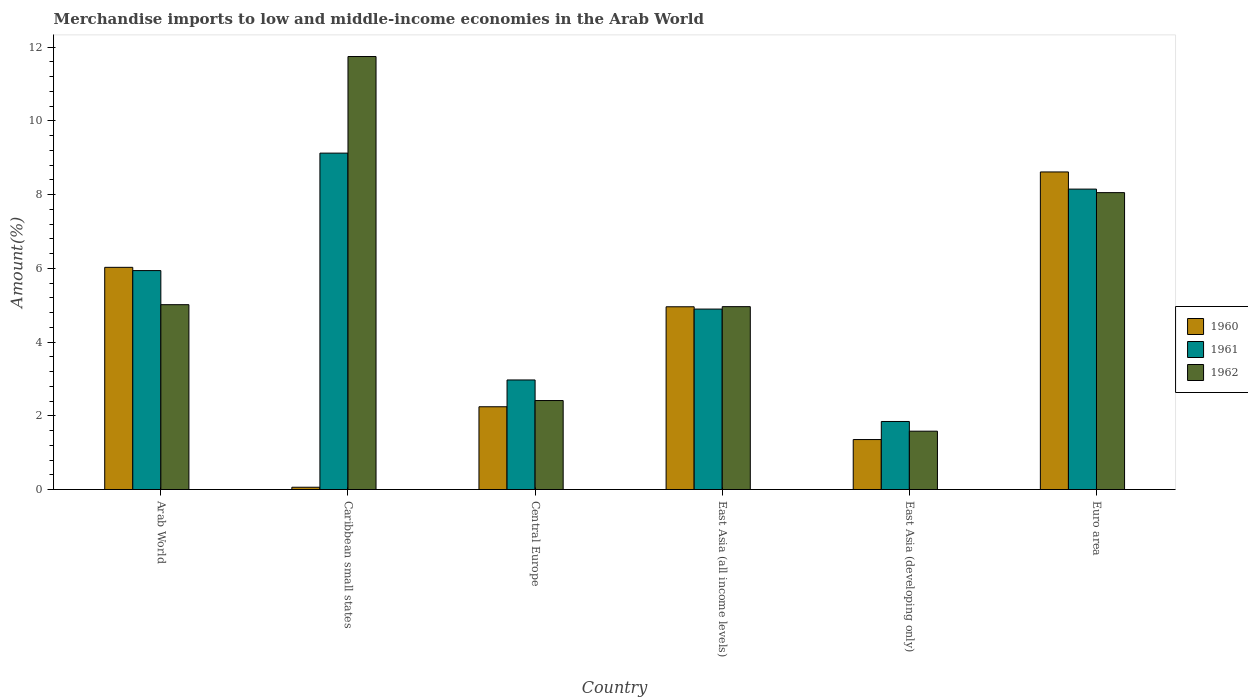How many different coloured bars are there?
Make the answer very short. 3. How many groups of bars are there?
Your answer should be compact. 6. Are the number of bars per tick equal to the number of legend labels?
Ensure brevity in your answer.  Yes. Are the number of bars on each tick of the X-axis equal?
Make the answer very short. Yes. What is the label of the 2nd group of bars from the left?
Give a very brief answer. Caribbean small states. In how many cases, is the number of bars for a given country not equal to the number of legend labels?
Your answer should be very brief. 0. What is the percentage of amount earned from merchandise imports in 1960 in Caribbean small states?
Offer a very short reply. 0.06. Across all countries, what is the maximum percentage of amount earned from merchandise imports in 1961?
Give a very brief answer. 9.13. Across all countries, what is the minimum percentage of amount earned from merchandise imports in 1962?
Your response must be concise. 1.58. In which country was the percentage of amount earned from merchandise imports in 1961 maximum?
Your response must be concise. Caribbean small states. In which country was the percentage of amount earned from merchandise imports in 1962 minimum?
Make the answer very short. East Asia (developing only). What is the total percentage of amount earned from merchandise imports in 1960 in the graph?
Make the answer very short. 23.27. What is the difference between the percentage of amount earned from merchandise imports in 1960 in Caribbean small states and that in Central Europe?
Offer a very short reply. -2.18. What is the difference between the percentage of amount earned from merchandise imports in 1962 in East Asia (all income levels) and the percentage of amount earned from merchandise imports in 1960 in Caribbean small states?
Provide a succinct answer. 4.9. What is the average percentage of amount earned from merchandise imports in 1962 per country?
Provide a succinct answer. 5.63. What is the difference between the percentage of amount earned from merchandise imports of/in 1962 and percentage of amount earned from merchandise imports of/in 1960 in Caribbean small states?
Provide a short and direct response. 11.69. What is the ratio of the percentage of amount earned from merchandise imports in 1961 in Arab World to that in East Asia (developing only)?
Your answer should be compact. 3.22. Is the difference between the percentage of amount earned from merchandise imports in 1962 in Caribbean small states and East Asia (developing only) greater than the difference between the percentage of amount earned from merchandise imports in 1960 in Caribbean small states and East Asia (developing only)?
Your answer should be compact. Yes. What is the difference between the highest and the second highest percentage of amount earned from merchandise imports in 1960?
Your response must be concise. 3.66. What is the difference between the highest and the lowest percentage of amount earned from merchandise imports in 1961?
Your answer should be very brief. 7.28. In how many countries, is the percentage of amount earned from merchandise imports in 1961 greater than the average percentage of amount earned from merchandise imports in 1961 taken over all countries?
Ensure brevity in your answer.  3. What does the 2nd bar from the left in Euro area represents?
Give a very brief answer. 1961. How many bars are there?
Provide a succinct answer. 18. How many countries are there in the graph?
Offer a very short reply. 6. What is the difference between two consecutive major ticks on the Y-axis?
Offer a very short reply. 2. Does the graph contain grids?
Give a very brief answer. No. How many legend labels are there?
Your answer should be compact. 3. What is the title of the graph?
Ensure brevity in your answer.  Merchandise imports to low and middle-income economies in the Arab World. Does "1962" appear as one of the legend labels in the graph?
Your answer should be compact. Yes. What is the label or title of the X-axis?
Your response must be concise. Country. What is the label or title of the Y-axis?
Give a very brief answer. Amount(%). What is the Amount(%) of 1960 in Arab World?
Make the answer very short. 6.03. What is the Amount(%) of 1961 in Arab World?
Ensure brevity in your answer.  5.94. What is the Amount(%) of 1962 in Arab World?
Offer a very short reply. 5.01. What is the Amount(%) in 1960 in Caribbean small states?
Offer a very short reply. 0.06. What is the Amount(%) of 1961 in Caribbean small states?
Ensure brevity in your answer.  9.13. What is the Amount(%) of 1962 in Caribbean small states?
Your answer should be compact. 11.75. What is the Amount(%) in 1960 in Central Europe?
Make the answer very short. 2.25. What is the Amount(%) of 1961 in Central Europe?
Your answer should be compact. 2.97. What is the Amount(%) in 1962 in Central Europe?
Your response must be concise. 2.41. What is the Amount(%) of 1960 in East Asia (all income levels)?
Your answer should be very brief. 4.96. What is the Amount(%) in 1961 in East Asia (all income levels)?
Your answer should be compact. 4.9. What is the Amount(%) in 1962 in East Asia (all income levels)?
Keep it short and to the point. 4.96. What is the Amount(%) in 1960 in East Asia (developing only)?
Give a very brief answer. 1.36. What is the Amount(%) of 1961 in East Asia (developing only)?
Make the answer very short. 1.85. What is the Amount(%) in 1962 in East Asia (developing only)?
Provide a succinct answer. 1.58. What is the Amount(%) of 1960 in Euro area?
Your response must be concise. 8.62. What is the Amount(%) in 1961 in Euro area?
Keep it short and to the point. 8.15. What is the Amount(%) of 1962 in Euro area?
Make the answer very short. 8.05. Across all countries, what is the maximum Amount(%) in 1960?
Keep it short and to the point. 8.62. Across all countries, what is the maximum Amount(%) in 1961?
Your answer should be compact. 9.13. Across all countries, what is the maximum Amount(%) in 1962?
Your answer should be compact. 11.75. Across all countries, what is the minimum Amount(%) of 1960?
Provide a short and direct response. 0.06. Across all countries, what is the minimum Amount(%) in 1961?
Your answer should be very brief. 1.85. Across all countries, what is the minimum Amount(%) in 1962?
Ensure brevity in your answer.  1.58. What is the total Amount(%) in 1960 in the graph?
Make the answer very short. 23.27. What is the total Amount(%) of 1961 in the graph?
Offer a terse response. 32.93. What is the total Amount(%) in 1962 in the graph?
Your answer should be compact. 33.78. What is the difference between the Amount(%) in 1960 in Arab World and that in Caribbean small states?
Offer a very short reply. 5.97. What is the difference between the Amount(%) in 1961 in Arab World and that in Caribbean small states?
Offer a terse response. -3.19. What is the difference between the Amount(%) of 1962 in Arab World and that in Caribbean small states?
Provide a succinct answer. -6.73. What is the difference between the Amount(%) of 1960 in Arab World and that in Central Europe?
Make the answer very short. 3.78. What is the difference between the Amount(%) in 1961 in Arab World and that in Central Europe?
Offer a very short reply. 2.97. What is the difference between the Amount(%) in 1962 in Arab World and that in Central Europe?
Provide a succinct answer. 2.6. What is the difference between the Amount(%) in 1960 in Arab World and that in East Asia (all income levels)?
Keep it short and to the point. 1.07. What is the difference between the Amount(%) of 1961 in Arab World and that in East Asia (all income levels)?
Your answer should be compact. 1.04. What is the difference between the Amount(%) of 1962 in Arab World and that in East Asia (all income levels)?
Give a very brief answer. 0.05. What is the difference between the Amount(%) in 1960 in Arab World and that in East Asia (developing only)?
Provide a succinct answer. 4.67. What is the difference between the Amount(%) of 1961 in Arab World and that in East Asia (developing only)?
Offer a very short reply. 4.09. What is the difference between the Amount(%) in 1962 in Arab World and that in East Asia (developing only)?
Keep it short and to the point. 3.43. What is the difference between the Amount(%) in 1960 in Arab World and that in Euro area?
Your answer should be compact. -2.59. What is the difference between the Amount(%) in 1961 in Arab World and that in Euro area?
Your answer should be very brief. -2.21. What is the difference between the Amount(%) in 1962 in Arab World and that in Euro area?
Offer a very short reply. -3.04. What is the difference between the Amount(%) of 1960 in Caribbean small states and that in Central Europe?
Your answer should be very brief. -2.18. What is the difference between the Amount(%) of 1961 in Caribbean small states and that in Central Europe?
Provide a short and direct response. 6.15. What is the difference between the Amount(%) in 1962 in Caribbean small states and that in Central Europe?
Keep it short and to the point. 9.33. What is the difference between the Amount(%) in 1960 in Caribbean small states and that in East Asia (all income levels)?
Provide a succinct answer. -4.9. What is the difference between the Amount(%) of 1961 in Caribbean small states and that in East Asia (all income levels)?
Your response must be concise. 4.23. What is the difference between the Amount(%) in 1962 in Caribbean small states and that in East Asia (all income levels)?
Your response must be concise. 6.79. What is the difference between the Amount(%) in 1960 in Caribbean small states and that in East Asia (developing only)?
Your answer should be very brief. -1.29. What is the difference between the Amount(%) of 1961 in Caribbean small states and that in East Asia (developing only)?
Offer a terse response. 7.28. What is the difference between the Amount(%) of 1962 in Caribbean small states and that in East Asia (developing only)?
Provide a succinct answer. 10.16. What is the difference between the Amount(%) of 1960 in Caribbean small states and that in Euro area?
Provide a short and direct response. -8.55. What is the difference between the Amount(%) in 1961 in Caribbean small states and that in Euro area?
Make the answer very short. 0.98. What is the difference between the Amount(%) of 1962 in Caribbean small states and that in Euro area?
Ensure brevity in your answer.  3.69. What is the difference between the Amount(%) of 1960 in Central Europe and that in East Asia (all income levels)?
Give a very brief answer. -2.71. What is the difference between the Amount(%) in 1961 in Central Europe and that in East Asia (all income levels)?
Provide a succinct answer. -1.92. What is the difference between the Amount(%) in 1962 in Central Europe and that in East Asia (all income levels)?
Your answer should be compact. -2.55. What is the difference between the Amount(%) in 1960 in Central Europe and that in East Asia (developing only)?
Provide a short and direct response. 0.89. What is the difference between the Amount(%) in 1961 in Central Europe and that in East Asia (developing only)?
Ensure brevity in your answer.  1.13. What is the difference between the Amount(%) in 1962 in Central Europe and that in East Asia (developing only)?
Offer a very short reply. 0.83. What is the difference between the Amount(%) of 1960 in Central Europe and that in Euro area?
Ensure brevity in your answer.  -6.37. What is the difference between the Amount(%) of 1961 in Central Europe and that in Euro area?
Your answer should be compact. -5.18. What is the difference between the Amount(%) in 1962 in Central Europe and that in Euro area?
Provide a succinct answer. -5.64. What is the difference between the Amount(%) in 1960 in East Asia (all income levels) and that in East Asia (developing only)?
Make the answer very short. 3.6. What is the difference between the Amount(%) in 1961 in East Asia (all income levels) and that in East Asia (developing only)?
Provide a succinct answer. 3.05. What is the difference between the Amount(%) of 1962 in East Asia (all income levels) and that in East Asia (developing only)?
Make the answer very short. 3.38. What is the difference between the Amount(%) of 1960 in East Asia (all income levels) and that in Euro area?
Make the answer very short. -3.66. What is the difference between the Amount(%) in 1961 in East Asia (all income levels) and that in Euro area?
Offer a very short reply. -3.26. What is the difference between the Amount(%) of 1962 in East Asia (all income levels) and that in Euro area?
Your answer should be very brief. -3.09. What is the difference between the Amount(%) of 1960 in East Asia (developing only) and that in Euro area?
Ensure brevity in your answer.  -7.26. What is the difference between the Amount(%) in 1961 in East Asia (developing only) and that in Euro area?
Keep it short and to the point. -6.3. What is the difference between the Amount(%) of 1962 in East Asia (developing only) and that in Euro area?
Give a very brief answer. -6.47. What is the difference between the Amount(%) in 1960 in Arab World and the Amount(%) in 1961 in Caribbean small states?
Give a very brief answer. -3.1. What is the difference between the Amount(%) of 1960 in Arab World and the Amount(%) of 1962 in Caribbean small states?
Provide a succinct answer. -5.72. What is the difference between the Amount(%) in 1961 in Arab World and the Amount(%) in 1962 in Caribbean small states?
Provide a succinct answer. -5.81. What is the difference between the Amount(%) of 1960 in Arab World and the Amount(%) of 1961 in Central Europe?
Make the answer very short. 3.06. What is the difference between the Amount(%) in 1960 in Arab World and the Amount(%) in 1962 in Central Europe?
Offer a very short reply. 3.61. What is the difference between the Amount(%) in 1961 in Arab World and the Amount(%) in 1962 in Central Europe?
Give a very brief answer. 3.53. What is the difference between the Amount(%) in 1960 in Arab World and the Amount(%) in 1961 in East Asia (all income levels)?
Make the answer very short. 1.13. What is the difference between the Amount(%) of 1960 in Arab World and the Amount(%) of 1962 in East Asia (all income levels)?
Offer a terse response. 1.07. What is the difference between the Amount(%) in 1961 in Arab World and the Amount(%) in 1962 in East Asia (all income levels)?
Keep it short and to the point. 0.98. What is the difference between the Amount(%) in 1960 in Arab World and the Amount(%) in 1961 in East Asia (developing only)?
Offer a very short reply. 4.18. What is the difference between the Amount(%) in 1960 in Arab World and the Amount(%) in 1962 in East Asia (developing only)?
Your answer should be compact. 4.45. What is the difference between the Amount(%) of 1961 in Arab World and the Amount(%) of 1962 in East Asia (developing only)?
Ensure brevity in your answer.  4.36. What is the difference between the Amount(%) of 1960 in Arab World and the Amount(%) of 1961 in Euro area?
Offer a very short reply. -2.12. What is the difference between the Amount(%) of 1960 in Arab World and the Amount(%) of 1962 in Euro area?
Offer a terse response. -2.03. What is the difference between the Amount(%) in 1961 in Arab World and the Amount(%) in 1962 in Euro area?
Provide a succinct answer. -2.12. What is the difference between the Amount(%) of 1960 in Caribbean small states and the Amount(%) of 1961 in Central Europe?
Give a very brief answer. -2.91. What is the difference between the Amount(%) of 1960 in Caribbean small states and the Amount(%) of 1962 in Central Europe?
Provide a succinct answer. -2.35. What is the difference between the Amount(%) in 1961 in Caribbean small states and the Amount(%) in 1962 in Central Europe?
Ensure brevity in your answer.  6.71. What is the difference between the Amount(%) of 1960 in Caribbean small states and the Amount(%) of 1961 in East Asia (all income levels)?
Your answer should be compact. -4.83. What is the difference between the Amount(%) of 1961 in Caribbean small states and the Amount(%) of 1962 in East Asia (all income levels)?
Ensure brevity in your answer.  4.17. What is the difference between the Amount(%) of 1960 in Caribbean small states and the Amount(%) of 1961 in East Asia (developing only)?
Provide a succinct answer. -1.78. What is the difference between the Amount(%) in 1960 in Caribbean small states and the Amount(%) in 1962 in East Asia (developing only)?
Your answer should be very brief. -1.52. What is the difference between the Amount(%) in 1961 in Caribbean small states and the Amount(%) in 1962 in East Asia (developing only)?
Provide a succinct answer. 7.54. What is the difference between the Amount(%) in 1960 in Caribbean small states and the Amount(%) in 1961 in Euro area?
Keep it short and to the point. -8.09. What is the difference between the Amount(%) of 1960 in Caribbean small states and the Amount(%) of 1962 in Euro area?
Provide a short and direct response. -7.99. What is the difference between the Amount(%) in 1961 in Caribbean small states and the Amount(%) in 1962 in Euro area?
Your response must be concise. 1.07. What is the difference between the Amount(%) in 1960 in Central Europe and the Amount(%) in 1961 in East Asia (all income levels)?
Make the answer very short. -2.65. What is the difference between the Amount(%) of 1960 in Central Europe and the Amount(%) of 1962 in East Asia (all income levels)?
Give a very brief answer. -2.72. What is the difference between the Amount(%) in 1961 in Central Europe and the Amount(%) in 1962 in East Asia (all income levels)?
Offer a terse response. -1.99. What is the difference between the Amount(%) in 1960 in Central Europe and the Amount(%) in 1961 in East Asia (developing only)?
Provide a short and direct response. 0.4. What is the difference between the Amount(%) in 1960 in Central Europe and the Amount(%) in 1962 in East Asia (developing only)?
Make the answer very short. 0.66. What is the difference between the Amount(%) of 1961 in Central Europe and the Amount(%) of 1962 in East Asia (developing only)?
Offer a very short reply. 1.39. What is the difference between the Amount(%) of 1960 in Central Europe and the Amount(%) of 1961 in Euro area?
Offer a terse response. -5.91. What is the difference between the Amount(%) of 1960 in Central Europe and the Amount(%) of 1962 in Euro area?
Provide a short and direct response. -5.81. What is the difference between the Amount(%) in 1961 in Central Europe and the Amount(%) in 1962 in Euro area?
Offer a very short reply. -5.08. What is the difference between the Amount(%) of 1960 in East Asia (all income levels) and the Amount(%) of 1961 in East Asia (developing only)?
Offer a very short reply. 3.11. What is the difference between the Amount(%) of 1960 in East Asia (all income levels) and the Amount(%) of 1962 in East Asia (developing only)?
Give a very brief answer. 3.38. What is the difference between the Amount(%) of 1961 in East Asia (all income levels) and the Amount(%) of 1962 in East Asia (developing only)?
Your answer should be compact. 3.31. What is the difference between the Amount(%) of 1960 in East Asia (all income levels) and the Amount(%) of 1961 in Euro area?
Make the answer very short. -3.19. What is the difference between the Amount(%) of 1960 in East Asia (all income levels) and the Amount(%) of 1962 in Euro area?
Your answer should be compact. -3.1. What is the difference between the Amount(%) of 1961 in East Asia (all income levels) and the Amount(%) of 1962 in Euro area?
Your answer should be compact. -3.16. What is the difference between the Amount(%) of 1960 in East Asia (developing only) and the Amount(%) of 1961 in Euro area?
Your answer should be compact. -6.8. What is the difference between the Amount(%) of 1960 in East Asia (developing only) and the Amount(%) of 1962 in Euro area?
Keep it short and to the point. -6.7. What is the difference between the Amount(%) of 1961 in East Asia (developing only) and the Amount(%) of 1962 in Euro area?
Your answer should be compact. -6.21. What is the average Amount(%) in 1960 per country?
Your answer should be very brief. 3.88. What is the average Amount(%) of 1961 per country?
Offer a very short reply. 5.49. What is the average Amount(%) in 1962 per country?
Provide a succinct answer. 5.63. What is the difference between the Amount(%) in 1960 and Amount(%) in 1961 in Arab World?
Your answer should be very brief. 0.09. What is the difference between the Amount(%) in 1960 and Amount(%) in 1962 in Arab World?
Offer a very short reply. 1.01. What is the difference between the Amount(%) in 1961 and Amount(%) in 1962 in Arab World?
Offer a very short reply. 0.93. What is the difference between the Amount(%) in 1960 and Amount(%) in 1961 in Caribbean small states?
Your response must be concise. -9.07. What is the difference between the Amount(%) of 1960 and Amount(%) of 1962 in Caribbean small states?
Give a very brief answer. -11.69. What is the difference between the Amount(%) of 1961 and Amount(%) of 1962 in Caribbean small states?
Your answer should be compact. -2.62. What is the difference between the Amount(%) of 1960 and Amount(%) of 1961 in Central Europe?
Provide a succinct answer. -0.73. What is the difference between the Amount(%) in 1960 and Amount(%) in 1962 in Central Europe?
Provide a succinct answer. -0.17. What is the difference between the Amount(%) of 1961 and Amount(%) of 1962 in Central Europe?
Ensure brevity in your answer.  0.56. What is the difference between the Amount(%) of 1960 and Amount(%) of 1961 in East Asia (all income levels)?
Make the answer very short. 0.06. What is the difference between the Amount(%) in 1960 and Amount(%) in 1962 in East Asia (all income levels)?
Provide a short and direct response. -0. What is the difference between the Amount(%) of 1961 and Amount(%) of 1962 in East Asia (all income levels)?
Give a very brief answer. -0.07. What is the difference between the Amount(%) in 1960 and Amount(%) in 1961 in East Asia (developing only)?
Keep it short and to the point. -0.49. What is the difference between the Amount(%) of 1960 and Amount(%) of 1962 in East Asia (developing only)?
Provide a short and direct response. -0.23. What is the difference between the Amount(%) in 1961 and Amount(%) in 1962 in East Asia (developing only)?
Offer a terse response. 0.26. What is the difference between the Amount(%) of 1960 and Amount(%) of 1961 in Euro area?
Offer a very short reply. 0.47. What is the difference between the Amount(%) in 1960 and Amount(%) in 1962 in Euro area?
Ensure brevity in your answer.  0.56. What is the difference between the Amount(%) of 1961 and Amount(%) of 1962 in Euro area?
Provide a short and direct response. 0.1. What is the ratio of the Amount(%) of 1960 in Arab World to that in Caribbean small states?
Make the answer very short. 97.81. What is the ratio of the Amount(%) in 1961 in Arab World to that in Caribbean small states?
Provide a succinct answer. 0.65. What is the ratio of the Amount(%) of 1962 in Arab World to that in Caribbean small states?
Your answer should be compact. 0.43. What is the ratio of the Amount(%) of 1960 in Arab World to that in Central Europe?
Make the answer very short. 2.68. What is the ratio of the Amount(%) in 1961 in Arab World to that in Central Europe?
Your answer should be compact. 2. What is the ratio of the Amount(%) in 1962 in Arab World to that in Central Europe?
Provide a succinct answer. 2.08. What is the ratio of the Amount(%) of 1960 in Arab World to that in East Asia (all income levels)?
Offer a very short reply. 1.22. What is the ratio of the Amount(%) in 1961 in Arab World to that in East Asia (all income levels)?
Your answer should be compact. 1.21. What is the ratio of the Amount(%) of 1962 in Arab World to that in East Asia (all income levels)?
Your response must be concise. 1.01. What is the ratio of the Amount(%) in 1960 in Arab World to that in East Asia (developing only)?
Offer a terse response. 4.45. What is the ratio of the Amount(%) of 1961 in Arab World to that in East Asia (developing only)?
Your answer should be compact. 3.22. What is the ratio of the Amount(%) of 1962 in Arab World to that in East Asia (developing only)?
Give a very brief answer. 3.17. What is the ratio of the Amount(%) of 1960 in Arab World to that in Euro area?
Make the answer very short. 0.7. What is the ratio of the Amount(%) in 1961 in Arab World to that in Euro area?
Your answer should be very brief. 0.73. What is the ratio of the Amount(%) in 1962 in Arab World to that in Euro area?
Give a very brief answer. 0.62. What is the ratio of the Amount(%) in 1960 in Caribbean small states to that in Central Europe?
Ensure brevity in your answer.  0.03. What is the ratio of the Amount(%) in 1961 in Caribbean small states to that in Central Europe?
Offer a terse response. 3.07. What is the ratio of the Amount(%) in 1962 in Caribbean small states to that in Central Europe?
Give a very brief answer. 4.87. What is the ratio of the Amount(%) of 1960 in Caribbean small states to that in East Asia (all income levels)?
Your answer should be compact. 0.01. What is the ratio of the Amount(%) in 1961 in Caribbean small states to that in East Asia (all income levels)?
Your response must be concise. 1.86. What is the ratio of the Amount(%) of 1962 in Caribbean small states to that in East Asia (all income levels)?
Offer a terse response. 2.37. What is the ratio of the Amount(%) in 1960 in Caribbean small states to that in East Asia (developing only)?
Offer a very short reply. 0.05. What is the ratio of the Amount(%) of 1961 in Caribbean small states to that in East Asia (developing only)?
Your answer should be very brief. 4.94. What is the ratio of the Amount(%) in 1962 in Caribbean small states to that in East Asia (developing only)?
Make the answer very short. 7.42. What is the ratio of the Amount(%) of 1960 in Caribbean small states to that in Euro area?
Your answer should be compact. 0.01. What is the ratio of the Amount(%) of 1961 in Caribbean small states to that in Euro area?
Your answer should be compact. 1.12. What is the ratio of the Amount(%) of 1962 in Caribbean small states to that in Euro area?
Offer a terse response. 1.46. What is the ratio of the Amount(%) in 1960 in Central Europe to that in East Asia (all income levels)?
Your answer should be very brief. 0.45. What is the ratio of the Amount(%) of 1961 in Central Europe to that in East Asia (all income levels)?
Make the answer very short. 0.61. What is the ratio of the Amount(%) of 1962 in Central Europe to that in East Asia (all income levels)?
Give a very brief answer. 0.49. What is the ratio of the Amount(%) in 1960 in Central Europe to that in East Asia (developing only)?
Keep it short and to the point. 1.66. What is the ratio of the Amount(%) in 1961 in Central Europe to that in East Asia (developing only)?
Your response must be concise. 1.61. What is the ratio of the Amount(%) of 1962 in Central Europe to that in East Asia (developing only)?
Offer a terse response. 1.53. What is the ratio of the Amount(%) of 1960 in Central Europe to that in Euro area?
Ensure brevity in your answer.  0.26. What is the ratio of the Amount(%) in 1961 in Central Europe to that in Euro area?
Your answer should be very brief. 0.36. What is the ratio of the Amount(%) in 1962 in Central Europe to that in Euro area?
Make the answer very short. 0.3. What is the ratio of the Amount(%) of 1960 in East Asia (all income levels) to that in East Asia (developing only)?
Offer a terse response. 3.66. What is the ratio of the Amount(%) in 1961 in East Asia (all income levels) to that in East Asia (developing only)?
Give a very brief answer. 2.65. What is the ratio of the Amount(%) of 1962 in East Asia (all income levels) to that in East Asia (developing only)?
Keep it short and to the point. 3.13. What is the ratio of the Amount(%) of 1960 in East Asia (all income levels) to that in Euro area?
Offer a terse response. 0.58. What is the ratio of the Amount(%) of 1961 in East Asia (all income levels) to that in Euro area?
Your answer should be very brief. 0.6. What is the ratio of the Amount(%) of 1962 in East Asia (all income levels) to that in Euro area?
Provide a short and direct response. 0.62. What is the ratio of the Amount(%) in 1960 in East Asia (developing only) to that in Euro area?
Your answer should be very brief. 0.16. What is the ratio of the Amount(%) of 1961 in East Asia (developing only) to that in Euro area?
Your response must be concise. 0.23. What is the ratio of the Amount(%) in 1962 in East Asia (developing only) to that in Euro area?
Provide a succinct answer. 0.2. What is the difference between the highest and the second highest Amount(%) in 1960?
Your response must be concise. 2.59. What is the difference between the highest and the second highest Amount(%) in 1961?
Provide a short and direct response. 0.98. What is the difference between the highest and the second highest Amount(%) of 1962?
Your response must be concise. 3.69. What is the difference between the highest and the lowest Amount(%) in 1960?
Offer a terse response. 8.55. What is the difference between the highest and the lowest Amount(%) in 1961?
Make the answer very short. 7.28. What is the difference between the highest and the lowest Amount(%) of 1962?
Ensure brevity in your answer.  10.16. 